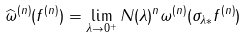Convert formula to latex. <formula><loc_0><loc_0><loc_500><loc_500>\widehat { \omega } ^ { ( n ) } ( f ^ { ( n ) } ) = \lim _ { \lambda \to 0 ^ { + } } N ( \lambda ) ^ { n } \omega ^ { ( n ) } ( \sigma _ { \lambda * } f ^ { ( n ) } )</formula> 